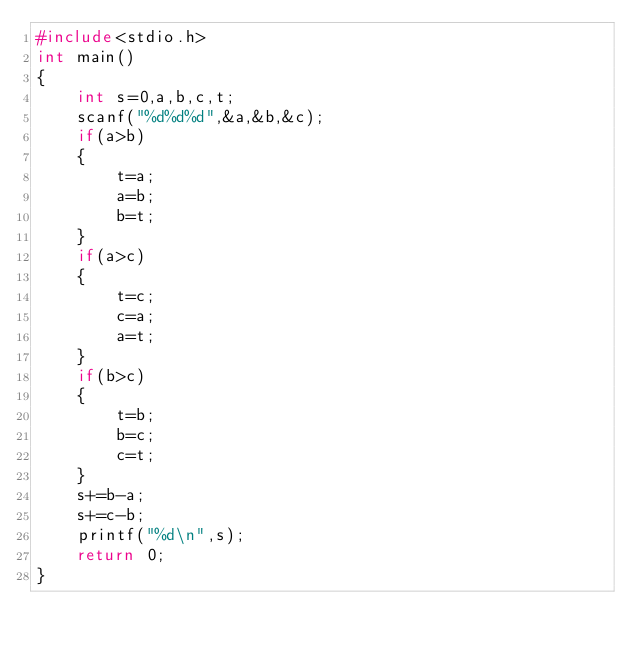<code> <loc_0><loc_0><loc_500><loc_500><_C++_>#include<stdio.h>
int main()
{
	int s=0,a,b,c,t;
	scanf("%d%d%d",&a,&b,&c);
	if(a>b)
	{
		t=a;
		a=b;
		b=t;
	}
	if(a>c)
	{
		t=c;
		c=a;
		a=t;
	}
	if(b>c)
	{
		t=b;
		b=c;
		c=t;
	}
	s+=b-a;
	s+=c-b;
	printf("%d\n",s);
	return 0;
}</code> 